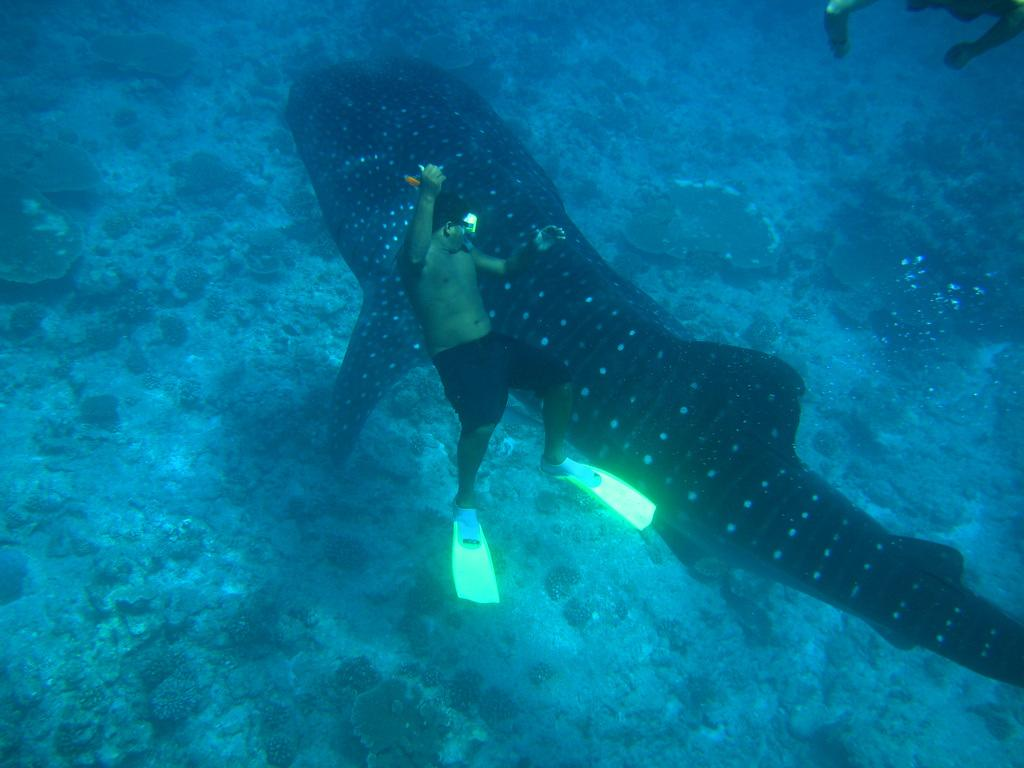What is the person doing in the water? The person is inside the water, but the specific activity cannot be determined from the provided facts. What type of sea animal is present in the water? There is a sea animal inside the water, but the specific type cannot be determined from the provided facts. How many chickens are visible in the image? There is no mention of chickens in the provided facts, so it cannot be determined if any are present in the image. 